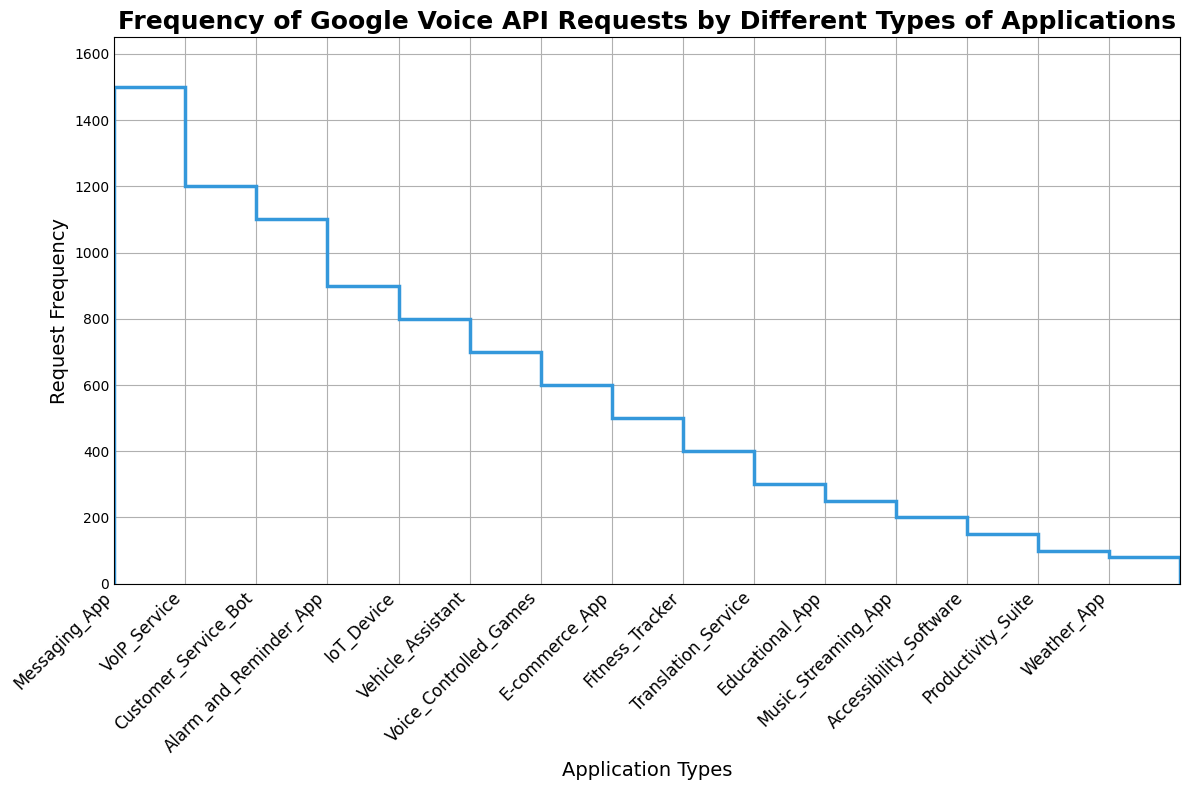What is the application type with the highest request frequency? The stairs plot shows the highest point on the y-axis and corresponds to the first application type on the x-axis, which is "Messaging_App."
Answer: Messaging_App Which application type has a lower request frequency, Customer_Service_Bot or Vehicle_Assistant? By looking at the heights of the steps, Customer_Service_Bot is higher on the y-axis compared to Vehicle_Assistant, indicating it has a higher frequency. Therefore, Vehicle_Assistant has a lower request frequency.
Answer: Vehicle_Assistant What is the total request frequency for IoT_Device and Fitness_Tracker combined? Locate the y-values for IoT_Device (800) and Fitness_Tracker (400), then sum these values: 800 + 400 = 1200.
Answer: 1200 How many application types have a request frequency greater than 900? Identify the steps higher than 900 on the y-axis. These include Messaging_App, VoIP_Service, and Customer_Service_Bot. This gives three application types.
Answer: 3 Is the request frequency of E-commerce_App greater than or equal to that of Educational_App? Compare the heights of the corresponding steps on the y-axis. E-commerce_App has a frequency of 500, and Educational_App has a frequency of 250. Since 500 is greater than 250, E-commerce_App has a greater frequency.
Answer: Yes What is the average request frequency of Alarm_and_Reminder_App and Music_Streaming_App? Locate their request frequencies: Alarm_and_Reminder_App (900) and Music_Streaming_App (200). Compute the average: (900 + 200) / 2 = 550.
Answer: 550 Which application types have request frequencies between 800 and 1200? Identify steps within this range on the y-axis. IoT_Device (800), Alarm_and_Reminder_App (900), Customer_Service_Bot (1100), and VoIP_Service (1200) fall within this range.
Answer: IoT_Device, Alarm_and_Reminder_App, Customer_Service_Bot, VoIP_Service What is the difference in request frequency between the highest and lowest application types? The highest frequency is for Messaging_App (1500) and the lowest is for Weather_App (80). Compute the difference: 1500 - 80 = 1420.
Answer: 1420 What is the median request frequency of the plotted data? Arrange the frequencies in ascending order and find the middle value. There are 15 values: [80, 100, 150, 200, 250, 300, 400, 500, 600, 700, 800, 900, 1100, 1200, 1500]. The median is the 8th value when sorted, which is 500.
Answer: 500 What is the application type with the second-highest request frequency? The second step from the top on the y-axis belongs to VoIP_Service, indicating it has the second-highest request frequency.
Answer: VoIP_Service 